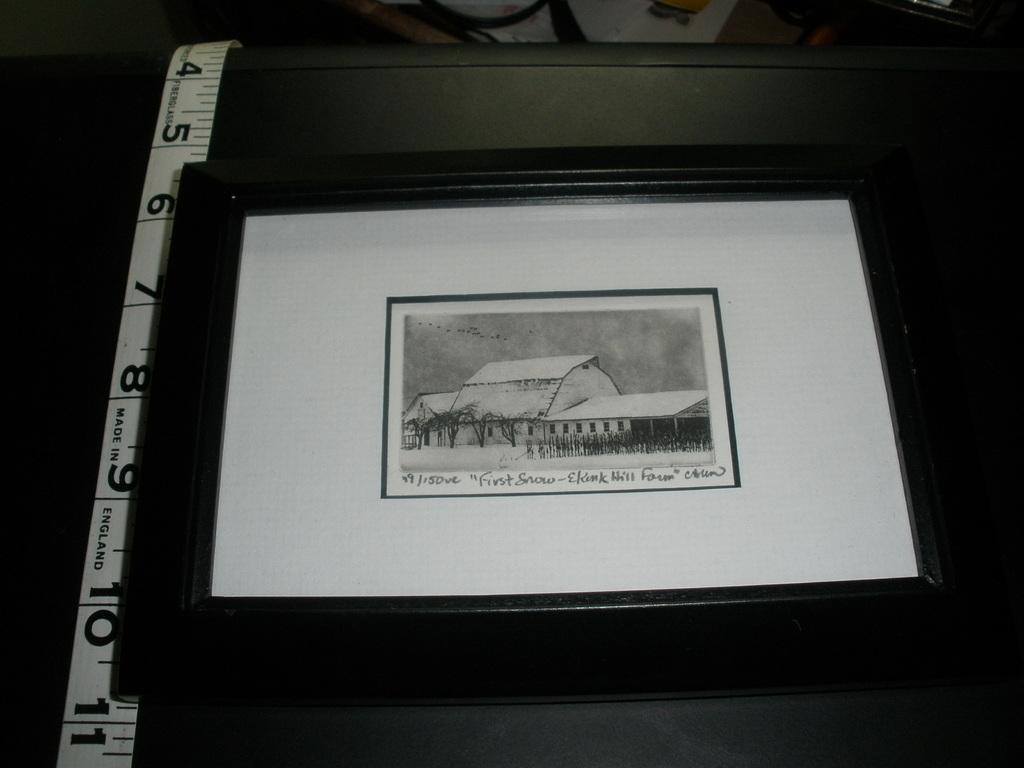What number is at the bottom?
Provide a short and direct response. 11. What is the name of this piece?
Make the answer very short. First snow. 